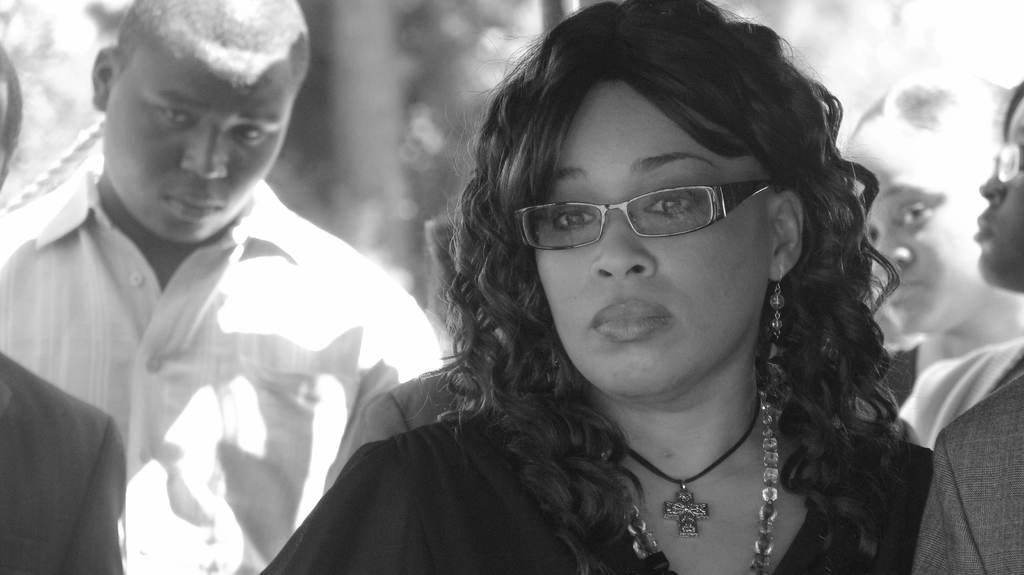Could you give a brief overview of what you see in this image? It is a black and white image, there is a woman in the foreground and around her there are other people. 